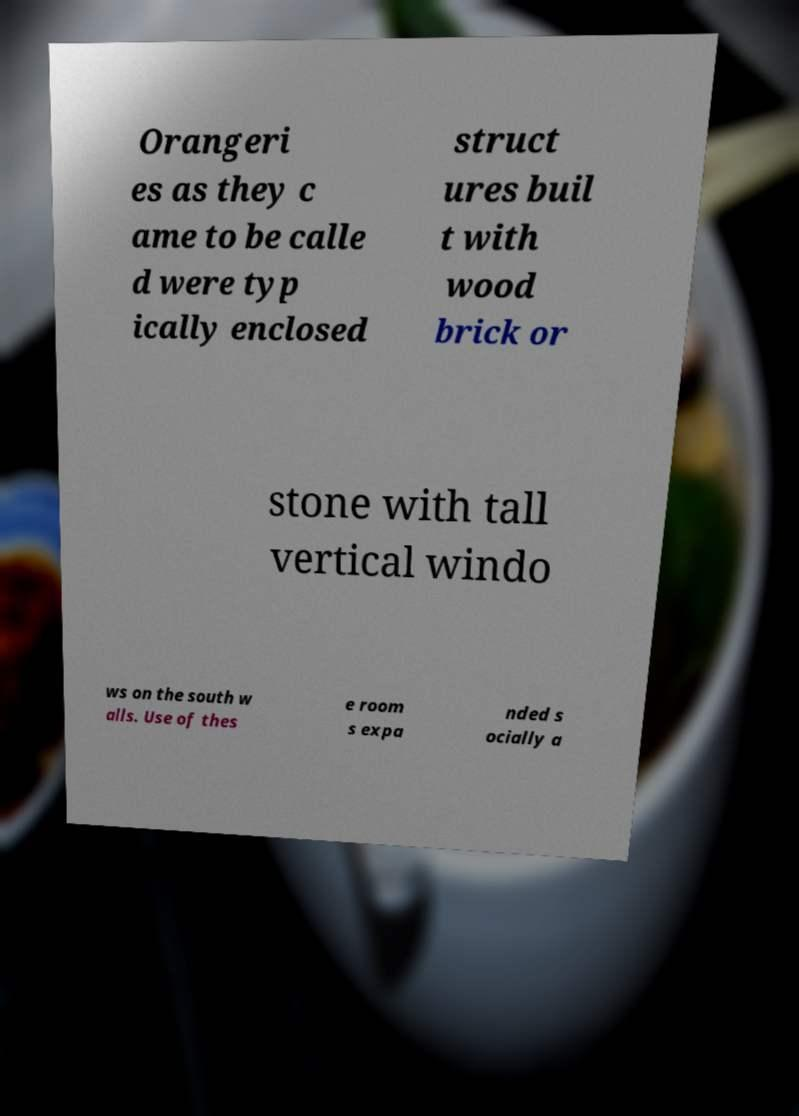I need the written content from this picture converted into text. Can you do that? Orangeri es as they c ame to be calle d were typ ically enclosed struct ures buil t with wood brick or stone with tall vertical windo ws on the south w alls. Use of thes e room s expa nded s ocially a 